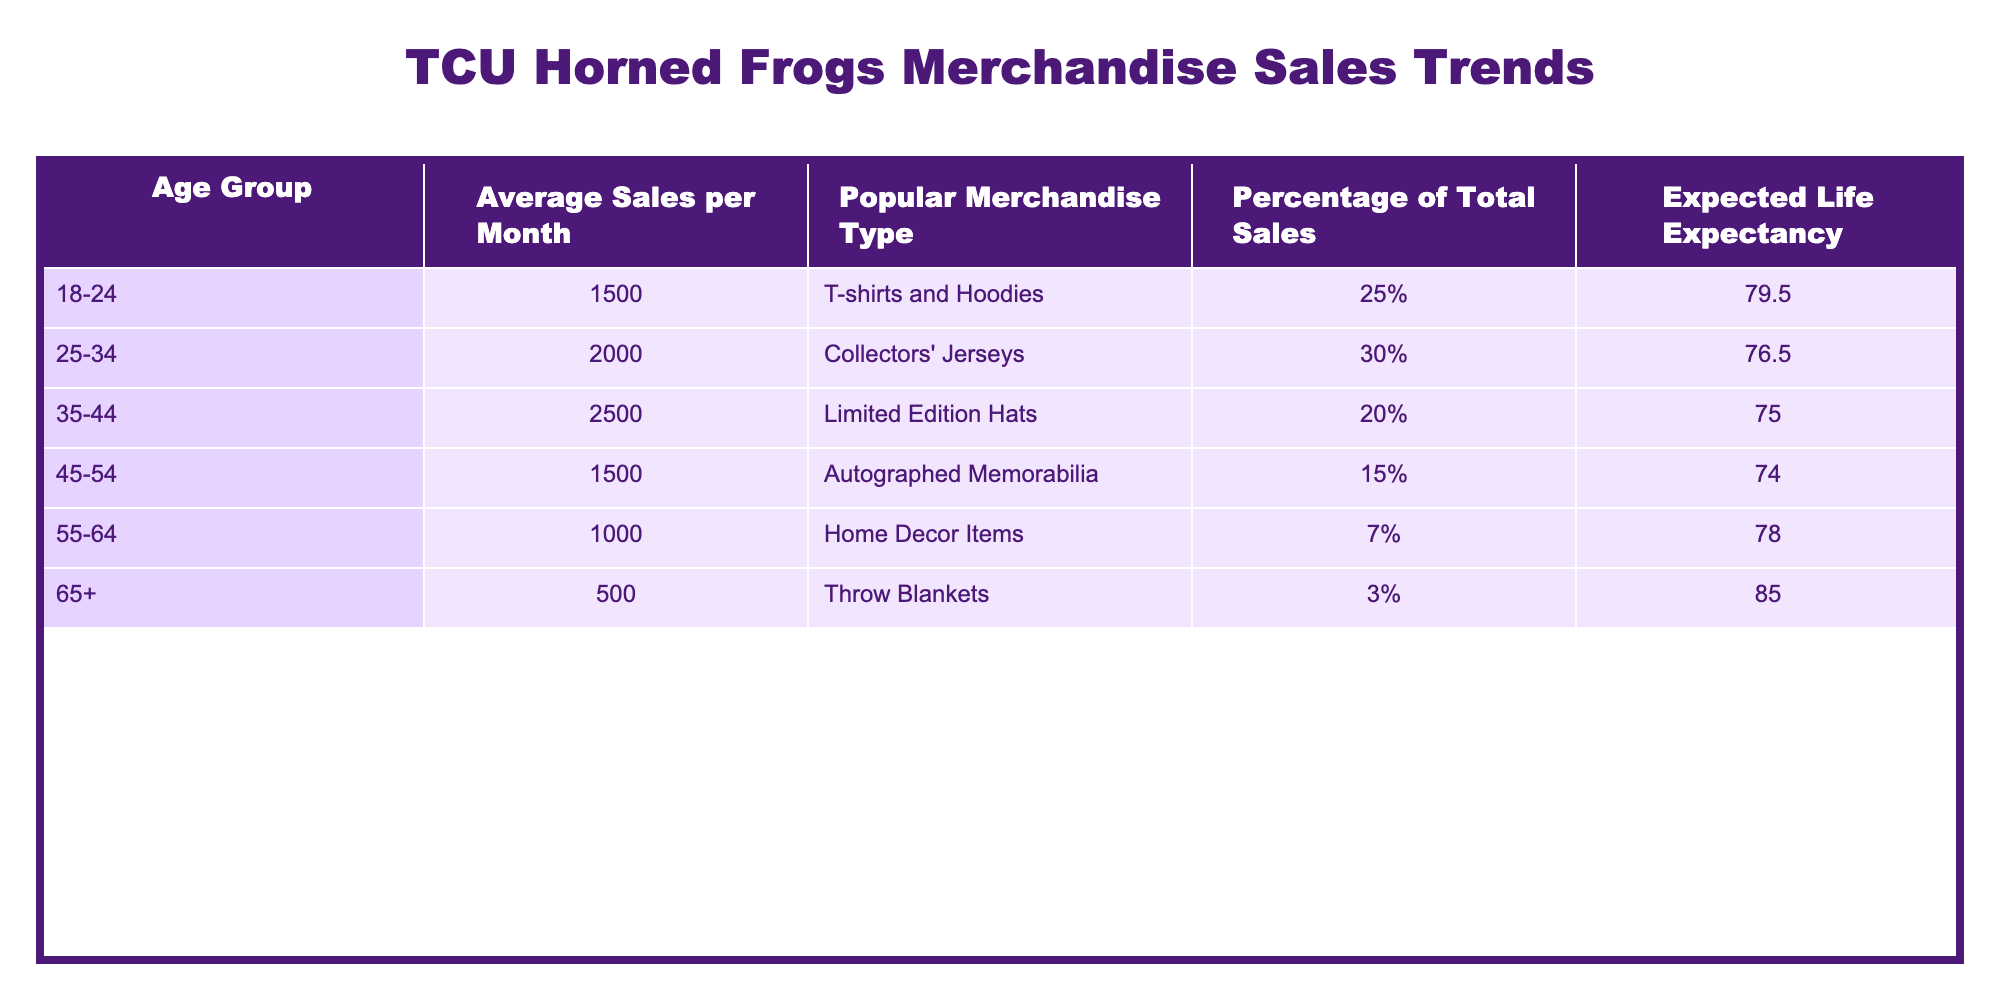What is the Average Sales per Month for the age group 25-34? The table lists the Average Sales per Month for each age group, and for the age group 25-34, it indicates 2000.00.
Answer: 2000.00 Which age group has the highest percentage of total sales? The percentage of total sales for each age group is shown in the table, and the age group 25-34 has the highest percentage at 30%.
Answer: 25-34 Is the expected life expectancy for the age group 65+ higher than that for the age group 55-64? The expected life expectancy for 65+ is 85.0 and for 55-64 it is 78.0. Since 85.0 is greater than 78.0, the statement is true.
Answer: Yes What is the total average sales per month for the age groups under 45? The average sales per month for the age groups under 45 are 1500.00 (18-24) + 2000.00 (25-34) + 2500.00 (35-44) = 6000.00.
Answer: 6000.00 Which popular merchandise type is most commonly associated with the age group 35-44? The table shows that the popular merchandise type for the age group 35-44 is Limited Edition Hats.
Answer: Limited Edition Hats Is the sales percentage for age group 55-64 higher than 10%? The table lists the percentage of total sales for age group 55-64 as 7%, which is less than 10%.
Answer: No What is the difference in average sales per month between the age groups 35-44 and 45-54? The average sales per month for age group 35-44 is 2500.00 and for 45-54 it is 1500.00. The difference is 2500.00 - 1500.00 = 1000.00.
Answer: 1000.00 How many age groups have an expected life expectancy below 75.0 years? The table has three age groups with an expected life expectancy below 75.0: 25-34 (76.5), 35-44 (75.0), and 45-54 (74.0). Therefore, 1 age group has an expected life expectancy below 75.0 years.
Answer: 1 What is the average expected life expectancy of all age groups? To calculate the average expected life expectancy, add the expected life expectancies: (79.5 + 76.5 + 75.0 + 74.0 + 78.0 + 85.0) = 468.0. Then divide by the number of groups, which is 6: 468.0 / 6 = 78.0.
Answer: 78.0 